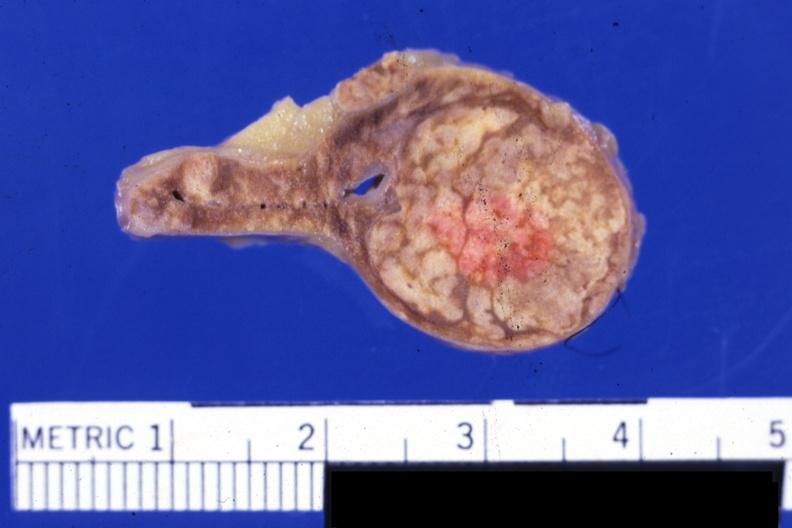s endocrine present?
Answer the question using a single word or phrase. Yes 